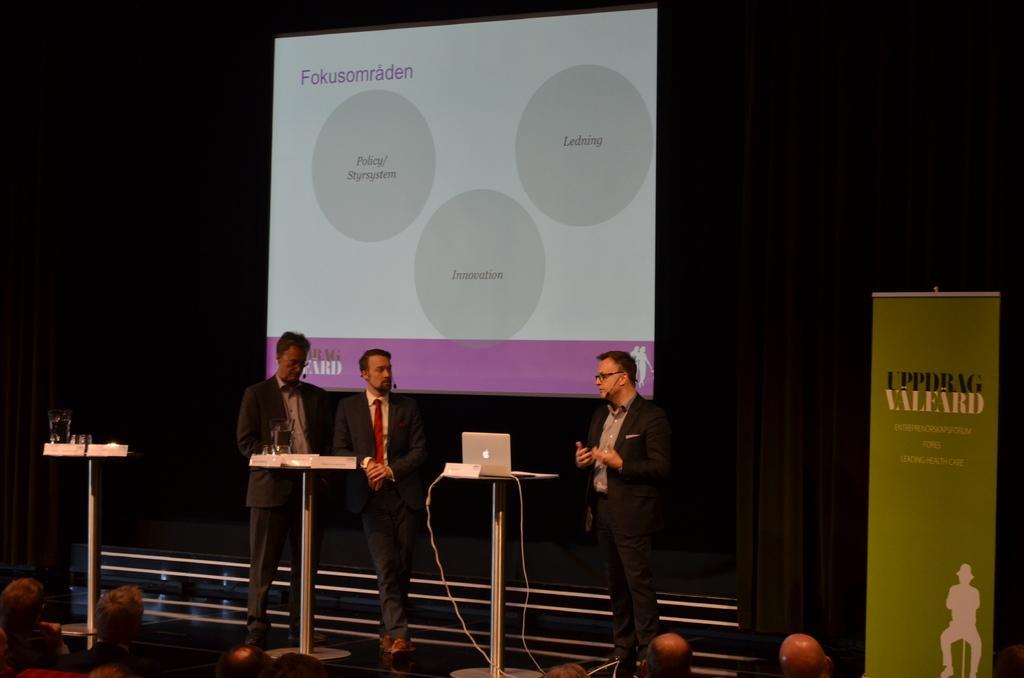Please provide a concise description of this image. In the picture it looks like some conference, there are three people standing in the front and there are three tables in between them, on the first table there is a laptop and on the right side there is a poster, in front of the men there are few people and in the background there is a projector screen and something is being displayed on that screen. 